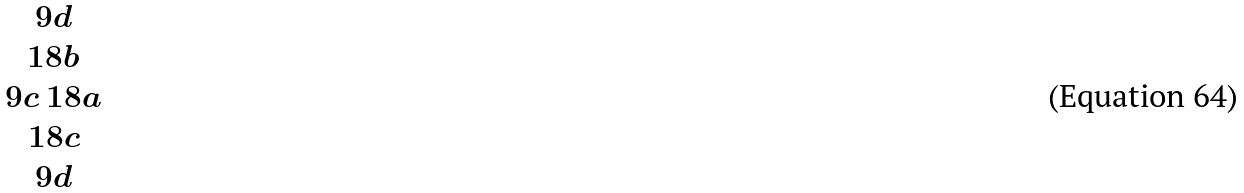Convert formula to latex. <formula><loc_0><loc_0><loc_500><loc_500>\begin{matrix} 9 d \\ 1 8 b \\ 9 c \ 1 8 a \\ 1 8 c \\ 9 d \end{matrix}</formula> 